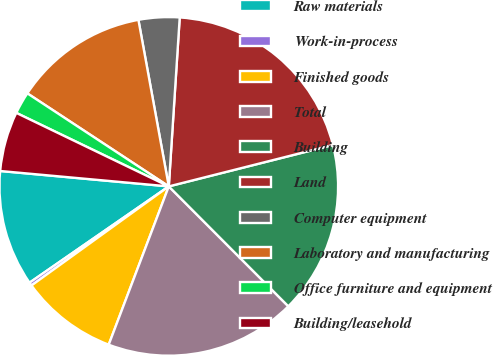Convert chart to OTSL. <chart><loc_0><loc_0><loc_500><loc_500><pie_chart><fcel>Raw materials<fcel>Work-in-process<fcel>Finished goods<fcel>Total<fcel>Building<fcel>Land<fcel>Computer equipment<fcel>Laboratory and manufacturing<fcel>Office furniture and equipment<fcel>Building/leasehold<nl><fcel>11.08%<fcel>0.32%<fcel>9.28%<fcel>18.25%<fcel>16.46%<fcel>20.04%<fcel>3.9%<fcel>12.87%<fcel>2.11%<fcel>5.7%<nl></chart> 